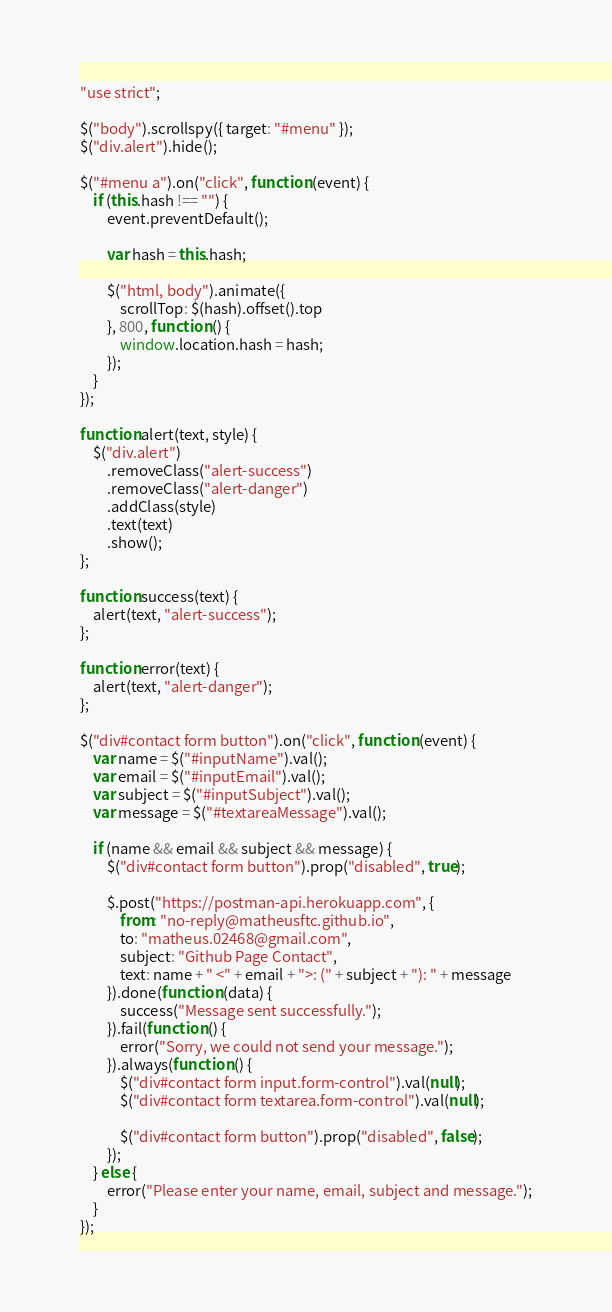<code> <loc_0><loc_0><loc_500><loc_500><_JavaScript_>"use strict";

$("body").scrollspy({ target: "#menu" });
$("div.alert").hide();

$("#menu a").on("click", function (event) {
    if (this.hash !== "") {
        event.preventDefault();

        var hash = this.hash;

        $("html, body").animate({
            scrollTop: $(hash).offset().top
        }, 800, function () {
            window.location.hash = hash;
        });
    }
});

function alert(text, style) {
    $("div.alert")
        .removeClass("alert-success")
        .removeClass("alert-danger")
        .addClass(style)
        .text(text)
        .show();
};

function success(text) {
    alert(text, "alert-success");
};

function error(text) {
    alert(text, "alert-danger");
};

$("div#contact form button").on("click", function (event) {
    var name = $("#inputName").val();
    var email = $("#inputEmail").val();
    var subject = $("#inputSubject").val();
    var message = $("#textareaMessage").val();

    if (name && email && subject && message) {
        $("div#contact form button").prop("disabled", true);

        $.post("https://postman-api.herokuapp.com", {
            from: "no-reply@matheusftc.github.io",
            to: "matheus.02468@gmail.com",
            subject: "Github Page Contact",
            text: name + " <" + email + ">: (" + subject + "): " + message
        }).done(function (data) {
            success("Message sent successfully.");
        }).fail(function () {
            error("Sorry, we could not send your message.");
        }).always(function () {
            $("div#contact form input.form-control").val(null);
            $("div#contact form textarea.form-control").val(null);
            
            $("div#contact form button").prop("disabled", false);
        });
    } else {
        error("Please enter your name, email, subject and message.");
    }
});</code> 